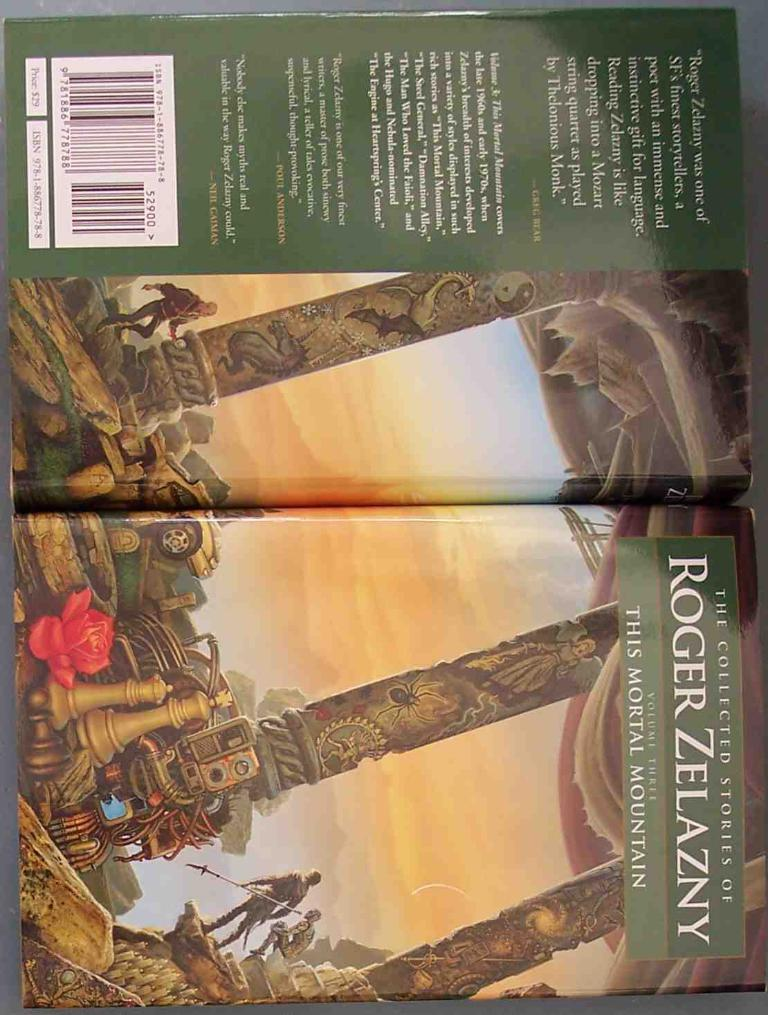Provide a one-sentence caption for the provided image. A display showing the back and front of the collected stories of Roger Zelazny. 